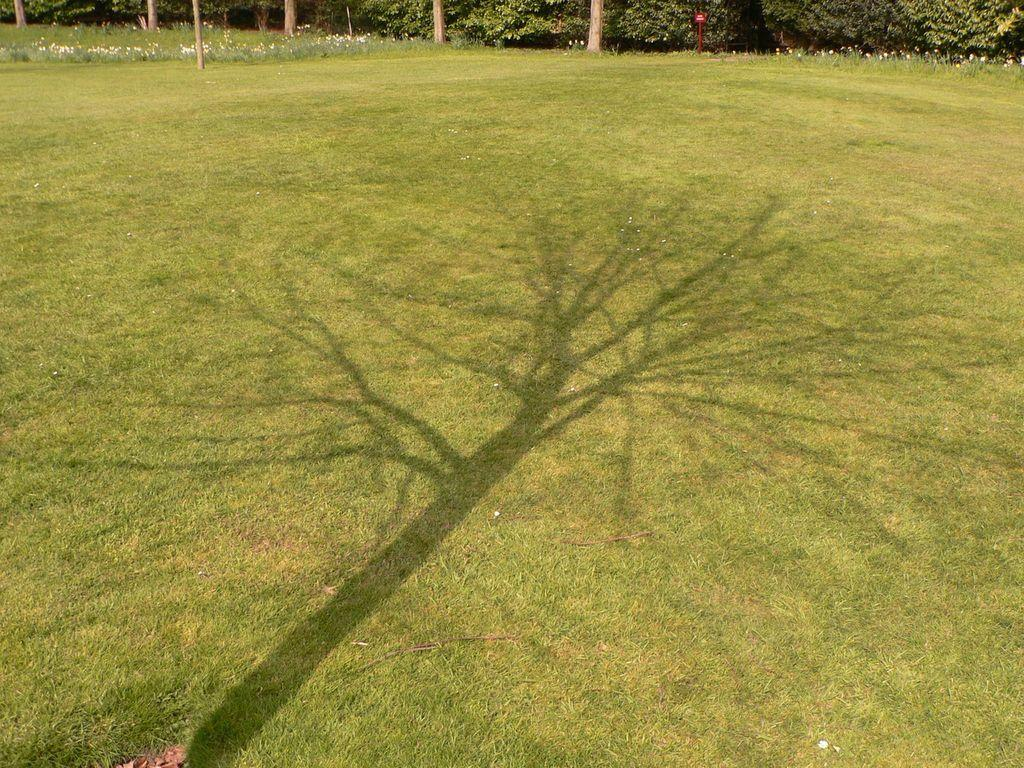What type of surface is visible in the image? There is a grass surface in the image. What can be seen on the grass surface? There is a tree shadow visible on the grass surface. What is visible in the background of the image? There are plants and a tree branch visible in the background of the image. How do the giants interact with the grass surface in the image? There are no giants present in the image, so their interaction with the grass surface cannot be determined. 